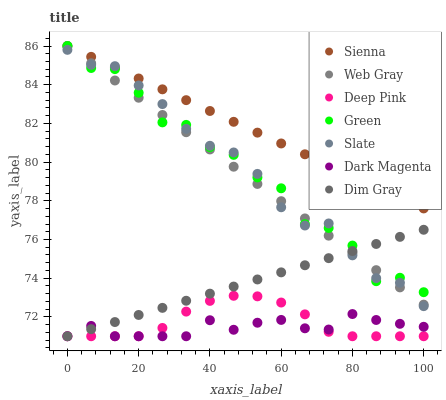Does Dark Magenta have the minimum area under the curve?
Answer yes or no. Yes. Does Sienna have the maximum area under the curve?
Answer yes or no. Yes. Does Slate have the minimum area under the curve?
Answer yes or no. No. Does Slate have the maximum area under the curve?
Answer yes or no. No. Is Dim Gray the smoothest?
Answer yes or no. Yes. Is Green the roughest?
Answer yes or no. Yes. Is Dark Magenta the smoothest?
Answer yes or no. No. Is Dark Magenta the roughest?
Answer yes or no. No. Does Dark Magenta have the lowest value?
Answer yes or no. Yes. Does Slate have the lowest value?
Answer yes or no. No. Does Green have the highest value?
Answer yes or no. Yes. Does Slate have the highest value?
Answer yes or no. No. Is Deep Pink less than Sienna?
Answer yes or no. Yes. Is Green greater than Dark Magenta?
Answer yes or no. Yes. Does Web Gray intersect Dim Gray?
Answer yes or no. Yes. Is Web Gray less than Dim Gray?
Answer yes or no. No. Is Web Gray greater than Dim Gray?
Answer yes or no. No. Does Deep Pink intersect Sienna?
Answer yes or no. No. 